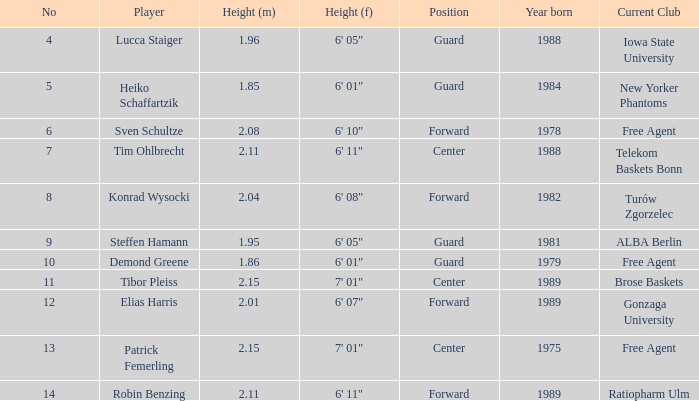11 meters. 6' 11". 